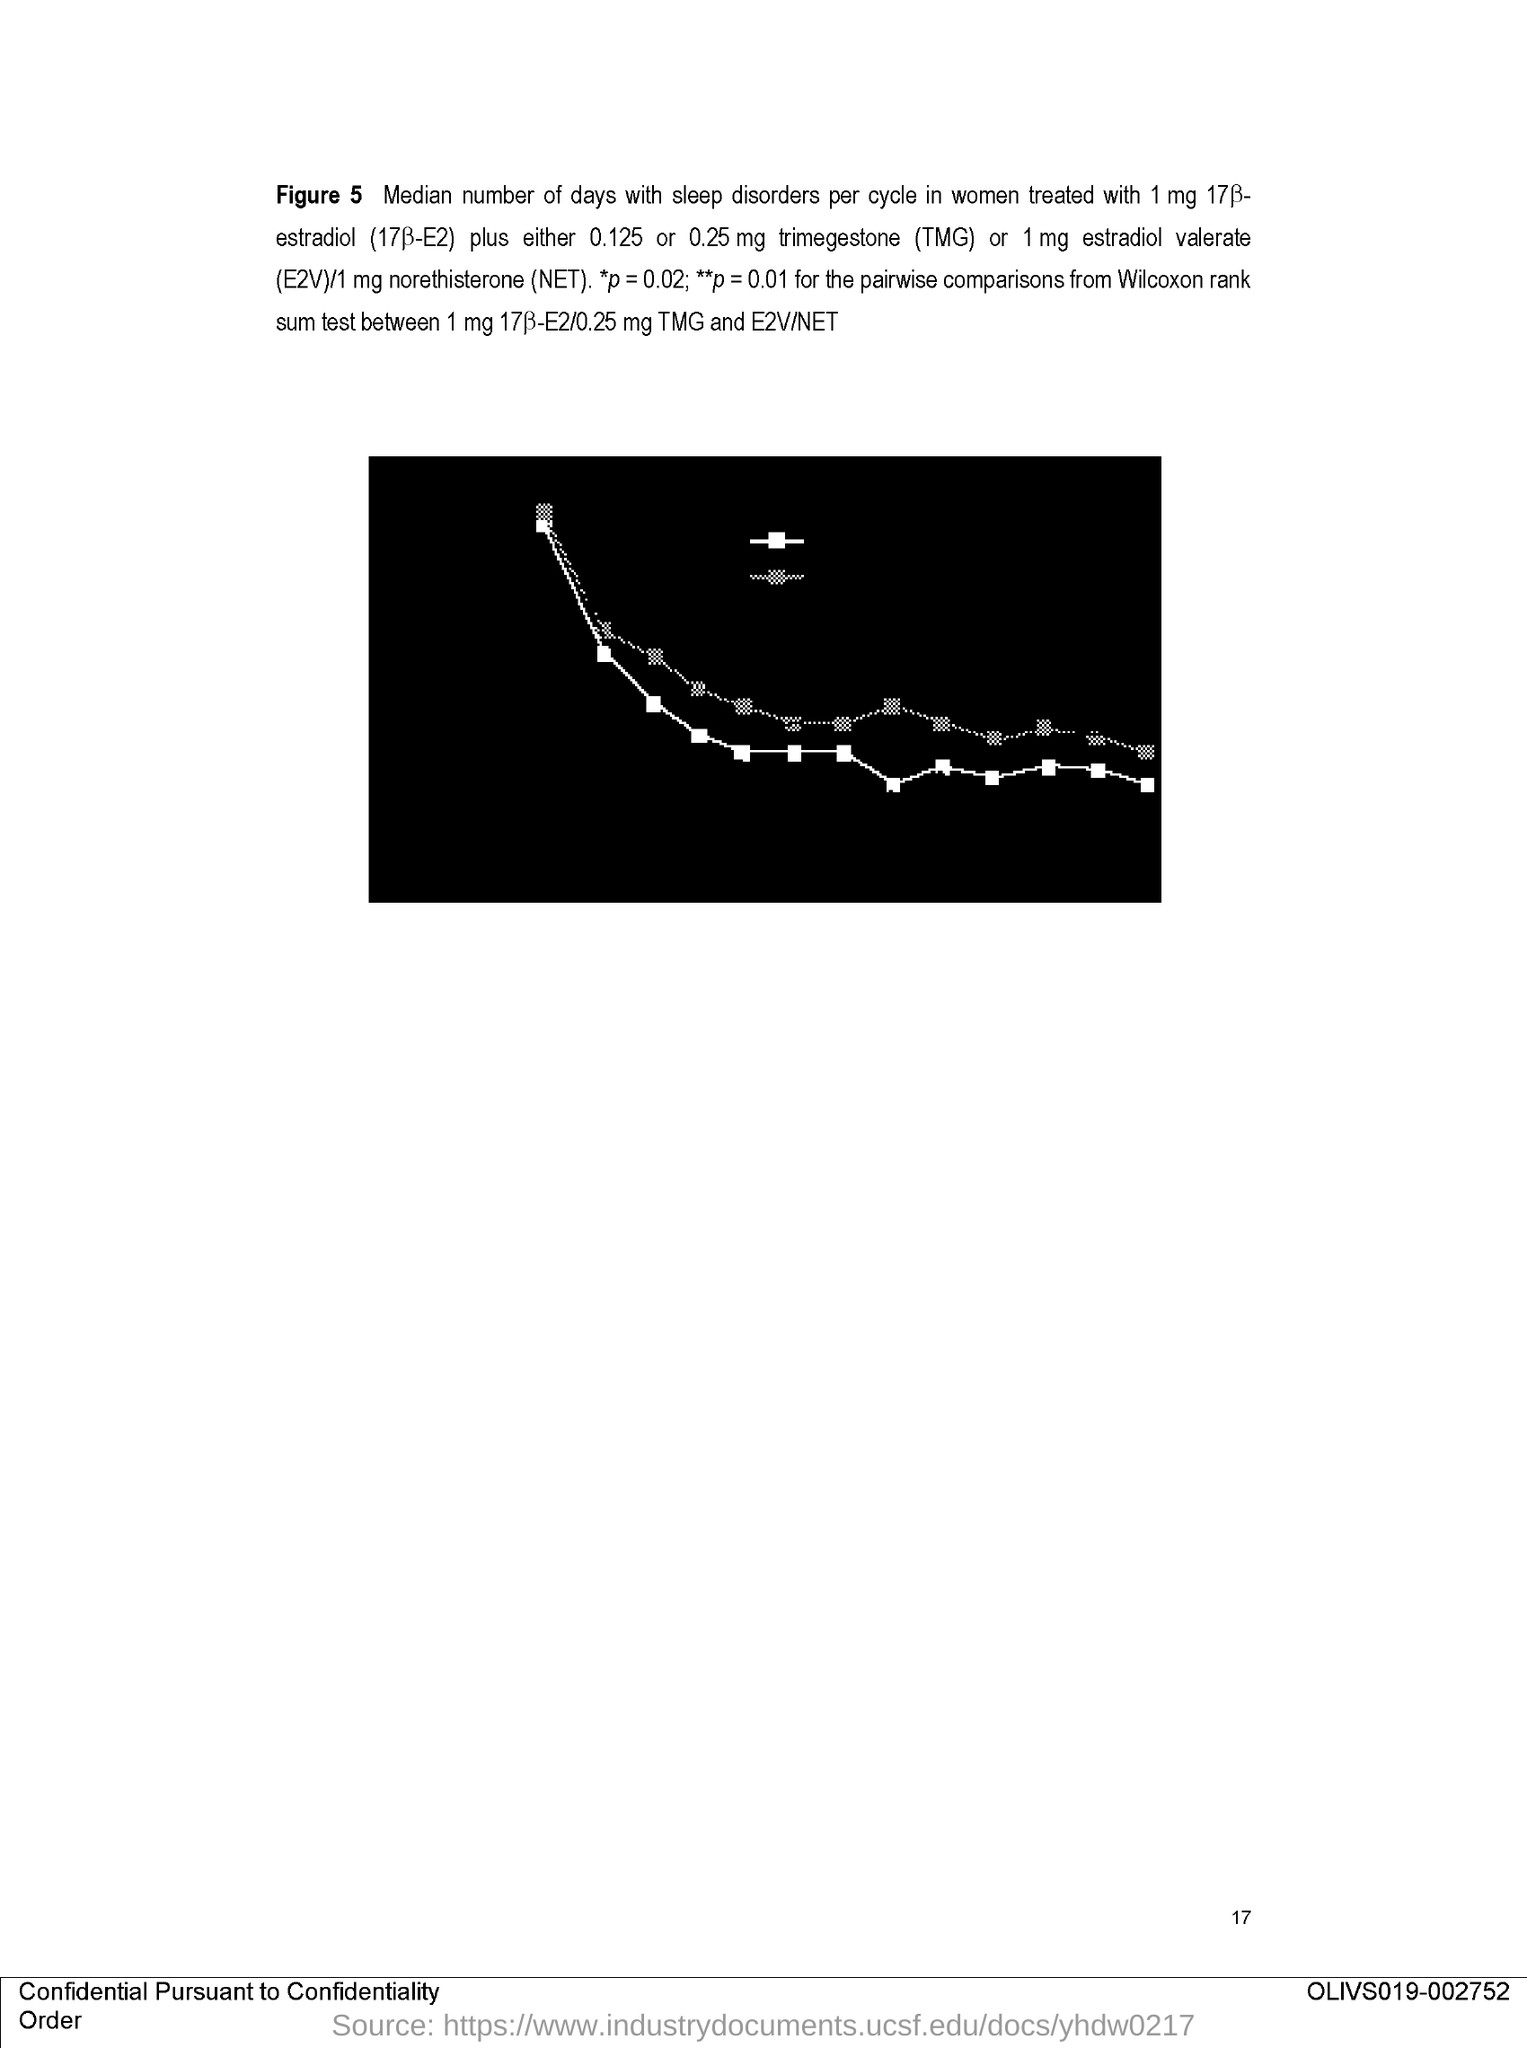Mention a couple of crucial points in this snapshot. The page number is 17. 